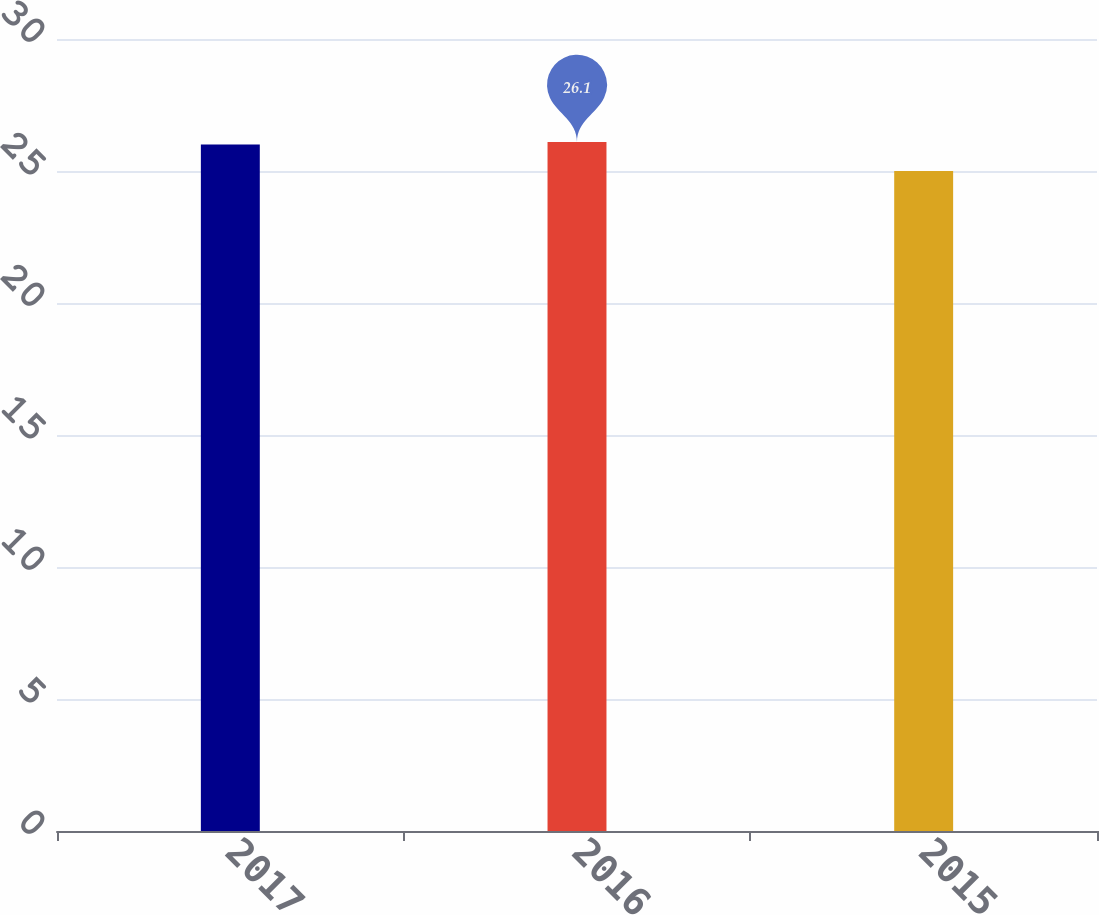Convert chart to OTSL. <chart><loc_0><loc_0><loc_500><loc_500><bar_chart><fcel>2017<fcel>2016<fcel>2015<nl><fcel>26<fcel>26.1<fcel>25<nl></chart> 